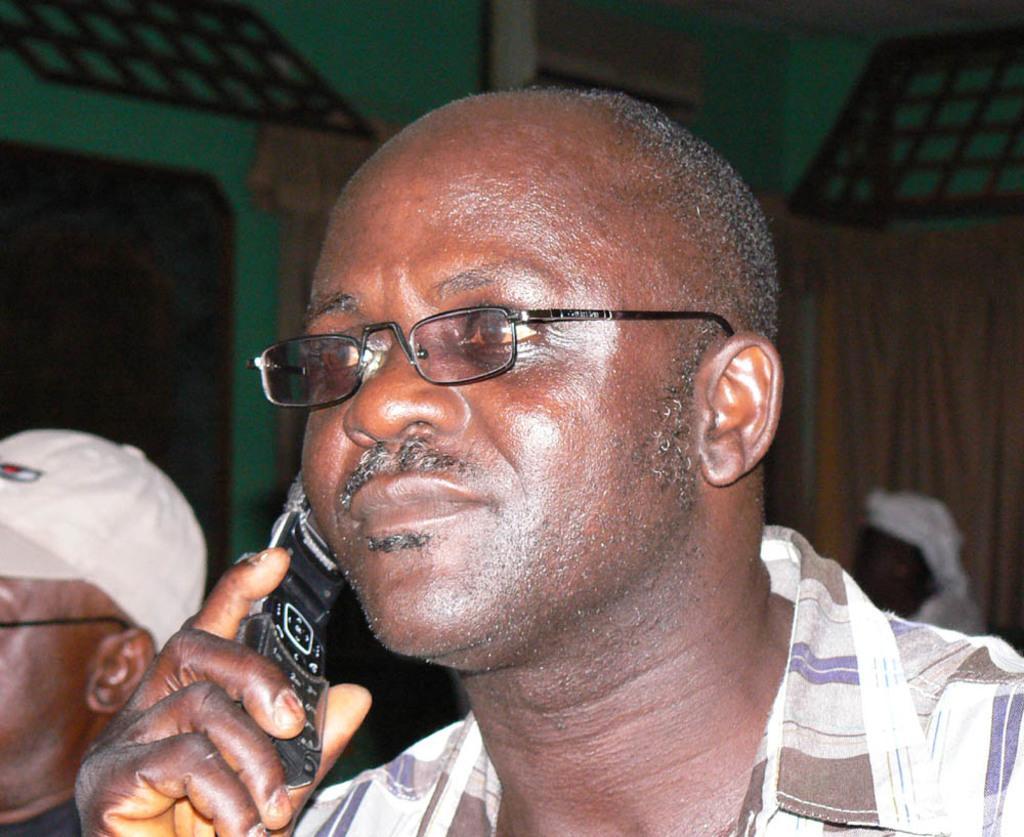Can you describe this image briefly? In this image we can see a man wearing the glasses and holding the mobile phone. We can also see two other persons. In the background we can see the curtain, door, air conditioner attached to the wall. 